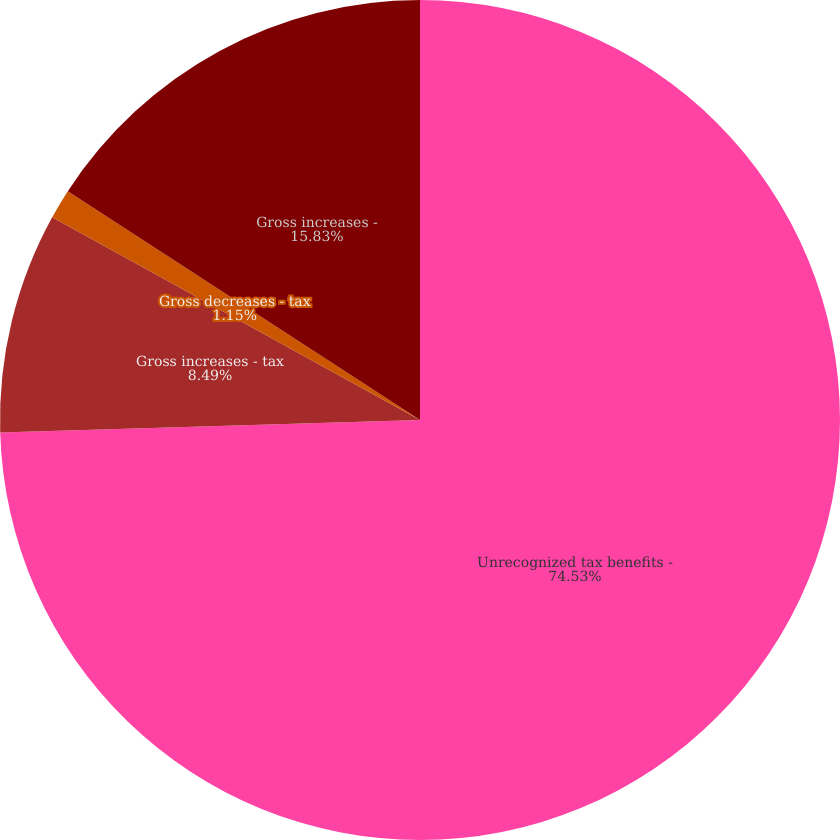<chart> <loc_0><loc_0><loc_500><loc_500><pie_chart><fcel>Unrecognized tax benefits -<fcel>Gross increases - tax<fcel>Gross decreases - tax<fcel>Gross increases -<nl><fcel>74.53%<fcel>8.49%<fcel>1.15%<fcel>15.83%<nl></chart> 